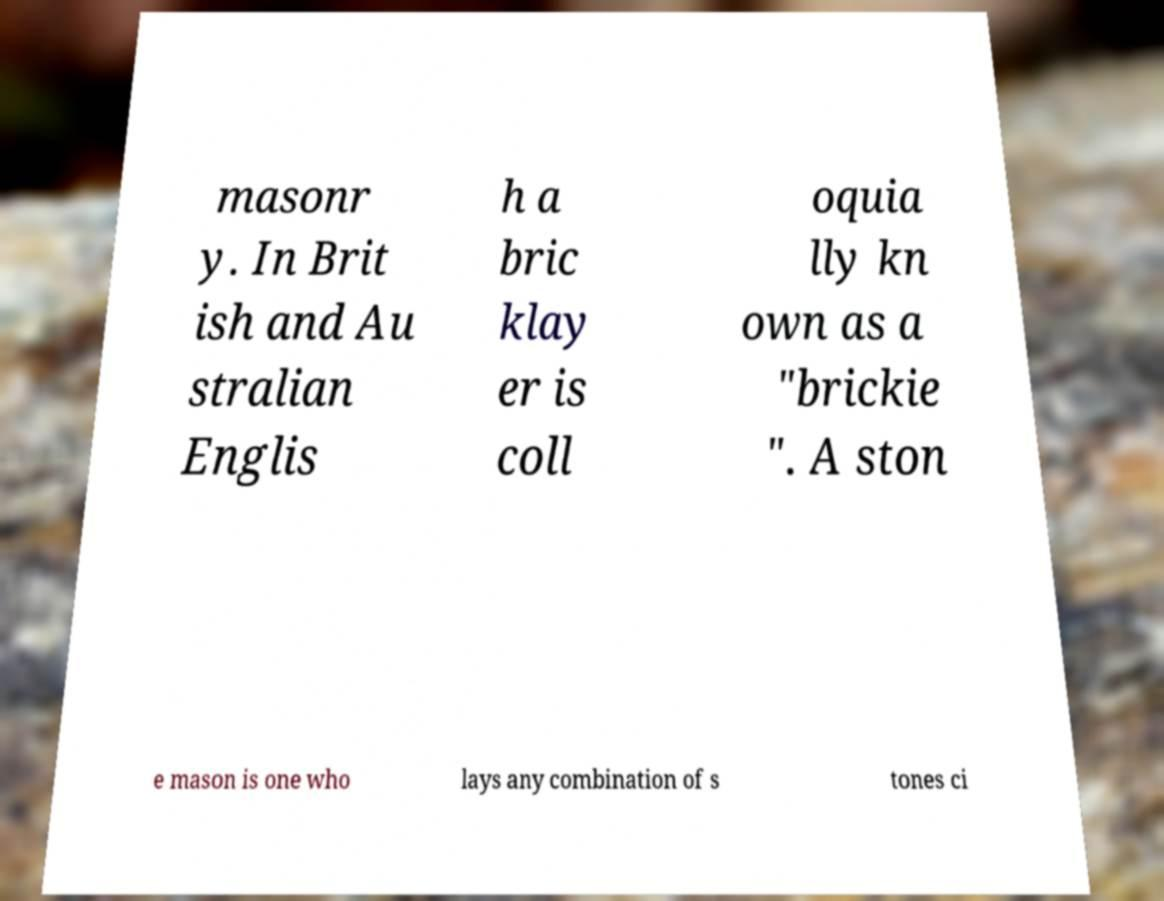Can you accurately transcribe the text from the provided image for me? masonr y. In Brit ish and Au stralian Englis h a bric klay er is coll oquia lly kn own as a "brickie ". A ston e mason is one who lays any combination of s tones ci 